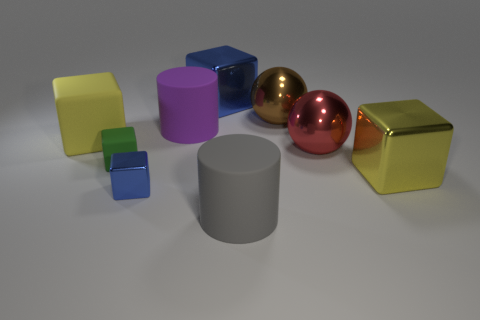Subtract all tiny rubber cubes. How many cubes are left? 4 Subtract all green cubes. How many cubes are left? 4 Subtract all brown blocks. Subtract all cyan cylinders. How many blocks are left? 5 Add 1 matte cubes. How many objects exist? 10 Subtract all cylinders. How many objects are left? 7 Add 3 tiny metallic cubes. How many tiny metallic cubes are left? 4 Add 3 small green rubber balls. How many small green rubber balls exist? 3 Subtract 0 red cylinders. How many objects are left? 9 Subtract all yellow metal blocks. Subtract all gray balls. How many objects are left? 8 